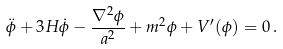<formula> <loc_0><loc_0><loc_500><loc_500>\ddot { \phi } + 3 H \dot { \phi } - \frac { \nabla ^ { 2 } \phi } { a ^ { 2 } } + m ^ { 2 } \phi + V ^ { \prime } ( \phi ) = 0 \, .</formula> 